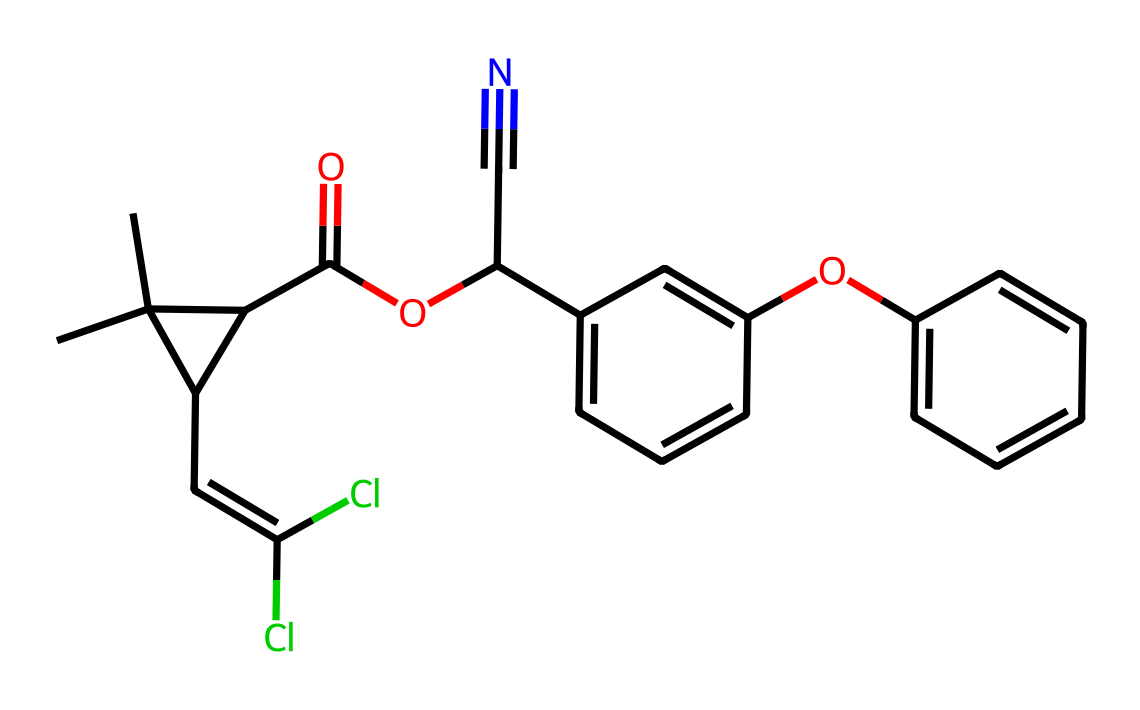How many carbon atoms are in permethrin? By analyzing the SMILES representation, each "C" represents a carbon atom. Counting each carbon symbol in the provided structure gives a total of 21 carbon atoms.
Answer: 21 What type of bonds are present in this chemical? The SMILES structure includes single bonds, double bonds (indicated by "="), and aromatic bonds (as seen in the cyclic parts with alternating double bonds). In total, there are both single and double bonds present in the molecule.
Answer: single and double bonds Is there any chlorine in permethrin? The "Cl" notation in the SMILES indicates the presence of chlorine atoms. By checking the structure for these symbols, we find there are two chlorine atoms present in the molecule.
Answer: Yes, two Which functional group is present due to the C=O notation? The "C(=O)" notation in the SMILES represents a carbonyl functional group, which is characteristic of esters or ketones. In this case, it indicates the presence of an ester group, which contributes to the properties of the chemical.
Answer: ester What property might the cyano group (-C#N) provide to permethrin? The cyano group (notated as "C#N") adds polarity and might enhance the chemical’s interaction with insect nervous systems, which is crucial for its insecticidal activity. This polarity can increase solubility and bioactivity.
Answer: increased polarity Does permethrin have any aromatic characteristics? By observing the presence of cyclic structures with alternating double bonds in the provided SMILES, we can conclude that there are aromatic characteristics within the molecule due to the benzene-like rings visible in the structure.
Answer: Yes, aromatic characteristics 